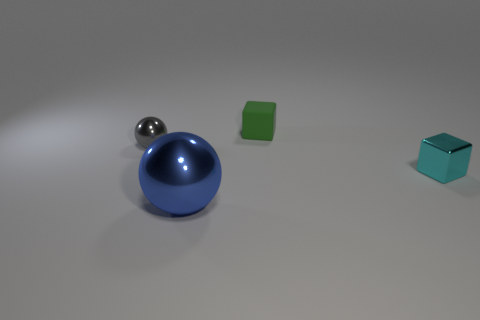There is a metal object in front of the tiny cyan metal thing; what is its size?
Ensure brevity in your answer.  Large. Is the size of the blue ball the same as the object that is behind the tiny sphere?
Offer a terse response. No. There is a sphere behind the small object on the right side of the matte thing; what is its color?
Offer a terse response. Gray. The green matte thing has what size?
Give a very brief answer. Small. Are there more large shiny objects in front of the cyan metal cube than matte things that are left of the large blue shiny object?
Give a very brief answer. Yes. How many gray metallic spheres are in front of the small thing left of the large blue metal thing?
Your response must be concise. 0. Do the tiny shiny thing that is on the left side of the cyan block and the cyan metal thing have the same shape?
Offer a terse response. No. What material is the other thing that is the same shape as the cyan metallic object?
Ensure brevity in your answer.  Rubber. How many metallic balls have the same size as the cyan thing?
Keep it short and to the point. 1. What is the color of the metal object that is to the right of the gray thing and behind the big blue sphere?
Provide a short and direct response. Cyan. 